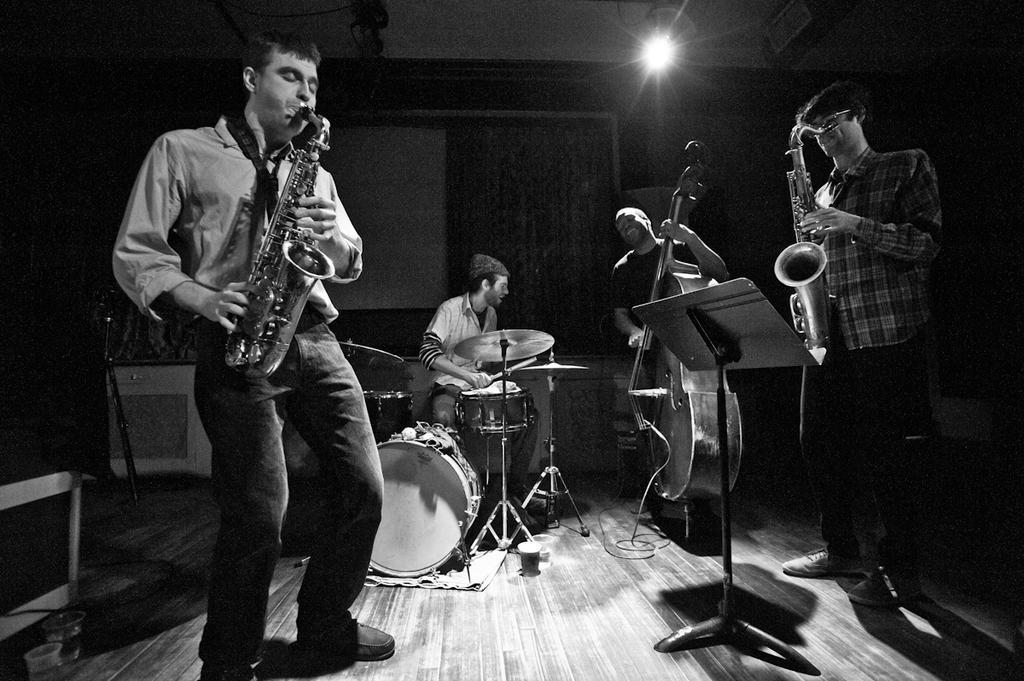What are the people in the image doing? The people in the image are playing musical instruments. Can you describe the lighting in the image? There is a light visible in the background of the image. How much sugar is present in the garden in the image? There is no mention of sugar or a garden in the image; it features people playing musical instruments with a light visible in the background. 